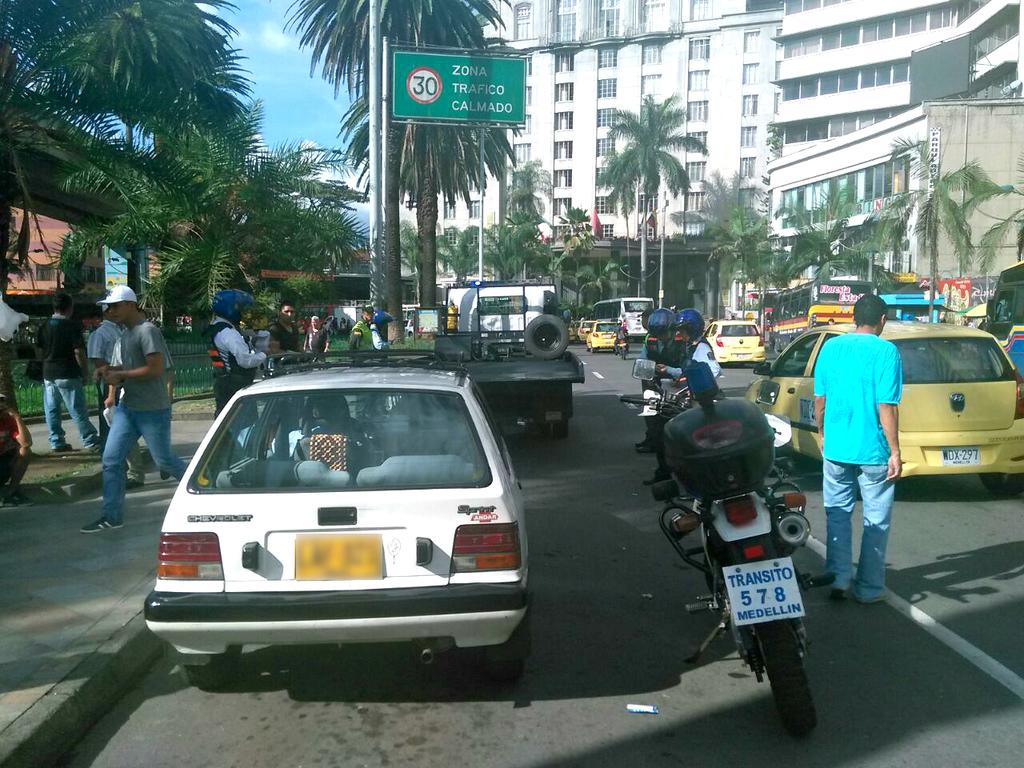<image>
Create a compact narrative representing the image presented. A busy street scene with a parked mtorbike with a Medellin licence plate. 